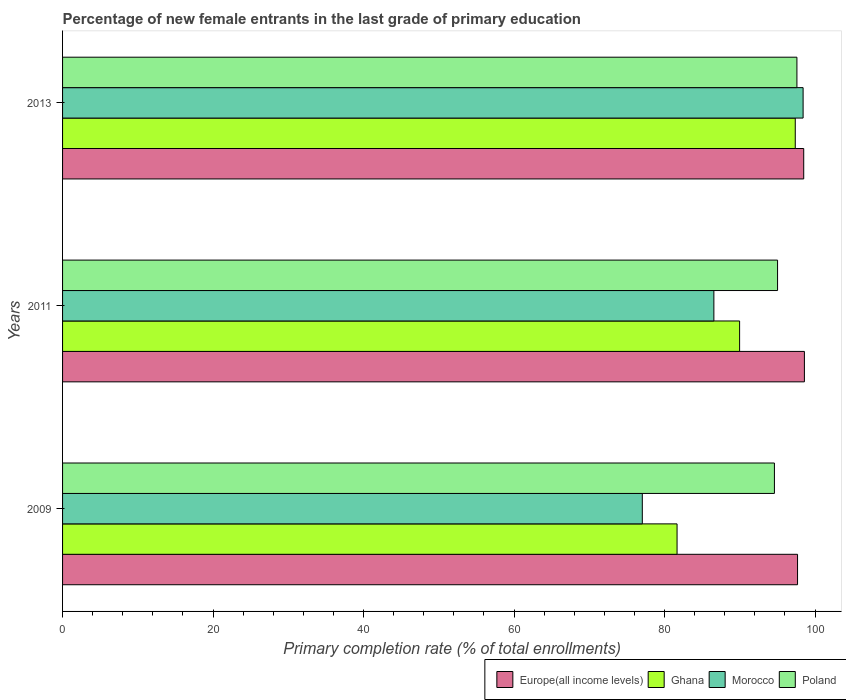How many groups of bars are there?
Ensure brevity in your answer.  3. Are the number of bars on each tick of the Y-axis equal?
Give a very brief answer. Yes. What is the label of the 3rd group of bars from the top?
Provide a succinct answer. 2009. What is the percentage of new female entrants in Morocco in 2013?
Offer a very short reply. 98.41. Across all years, what is the maximum percentage of new female entrants in Ghana?
Make the answer very short. 97.37. Across all years, what is the minimum percentage of new female entrants in Poland?
Your response must be concise. 94.6. In which year was the percentage of new female entrants in Morocco minimum?
Your answer should be compact. 2009. What is the total percentage of new female entrants in Ghana in the graph?
Ensure brevity in your answer.  269. What is the difference between the percentage of new female entrants in Morocco in 2009 and that in 2013?
Give a very brief answer. -21.37. What is the difference between the percentage of new female entrants in Europe(all income levels) in 2009 and the percentage of new female entrants in Morocco in 2013?
Your answer should be compact. -0.74. What is the average percentage of new female entrants in Ghana per year?
Your answer should be very brief. 89.67. In the year 2009, what is the difference between the percentage of new female entrants in Ghana and percentage of new female entrants in Poland?
Ensure brevity in your answer.  -12.94. What is the ratio of the percentage of new female entrants in Europe(all income levels) in 2009 to that in 2011?
Keep it short and to the point. 0.99. What is the difference between the highest and the second highest percentage of new female entrants in Europe(all income levels)?
Offer a terse response. 0.09. What is the difference between the highest and the lowest percentage of new female entrants in Europe(all income levels)?
Ensure brevity in your answer.  0.91. In how many years, is the percentage of new female entrants in Europe(all income levels) greater than the average percentage of new female entrants in Europe(all income levels) taken over all years?
Provide a short and direct response. 2. Is the sum of the percentage of new female entrants in Poland in 2009 and 2011 greater than the maximum percentage of new female entrants in Europe(all income levels) across all years?
Offer a very short reply. Yes. What does the 4th bar from the top in 2013 represents?
Your answer should be compact. Europe(all income levels). What does the 3rd bar from the bottom in 2011 represents?
Ensure brevity in your answer.  Morocco. How many bars are there?
Your answer should be very brief. 12. How many years are there in the graph?
Your answer should be very brief. 3. Are the values on the major ticks of X-axis written in scientific E-notation?
Provide a short and direct response. No. Does the graph contain grids?
Make the answer very short. No. How are the legend labels stacked?
Keep it short and to the point. Horizontal. What is the title of the graph?
Your answer should be compact. Percentage of new female entrants in the last grade of primary education. What is the label or title of the X-axis?
Ensure brevity in your answer.  Primary completion rate (% of total enrollments). What is the label or title of the Y-axis?
Your answer should be compact. Years. What is the Primary completion rate (% of total enrollments) in Europe(all income levels) in 2009?
Your response must be concise. 97.67. What is the Primary completion rate (% of total enrollments) in Ghana in 2009?
Give a very brief answer. 81.66. What is the Primary completion rate (% of total enrollments) in Morocco in 2009?
Offer a terse response. 77.04. What is the Primary completion rate (% of total enrollments) in Poland in 2009?
Give a very brief answer. 94.6. What is the Primary completion rate (% of total enrollments) in Europe(all income levels) in 2011?
Your answer should be very brief. 98.58. What is the Primary completion rate (% of total enrollments) of Ghana in 2011?
Offer a very short reply. 89.97. What is the Primary completion rate (% of total enrollments) of Morocco in 2011?
Provide a short and direct response. 86.55. What is the Primary completion rate (% of total enrollments) in Poland in 2011?
Keep it short and to the point. 95.02. What is the Primary completion rate (% of total enrollments) in Europe(all income levels) in 2013?
Provide a short and direct response. 98.49. What is the Primary completion rate (% of total enrollments) in Ghana in 2013?
Offer a very short reply. 97.37. What is the Primary completion rate (% of total enrollments) in Morocco in 2013?
Make the answer very short. 98.41. What is the Primary completion rate (% of total enrollments) in Poland in 2013?
Keep it short and to the point. 97.59. Across all years, what is the maximum Primary completion rate (% of total enrollments) of Europe(all income levels)?
Offer a very short reply. 98.58. Across all years, what is the maximum Primary completion rate (% of total enrollments) in Ghana?
Offer a very short reply. 97.37. Across all years, what is the maximum Primary completion rate (% of total enrollments) in Morocco?
Offer a terse response. 98.41. Across all years, what is the maximum Primary completion rate (% of total enrollments) in Poland?
Your response must be concise. 97.59. Across all years, what is the minimum Primary completion rate (% of total enrollments) in Europe(all income levels)?
Make the answer very short. 97.67. Across all years, what is the minimum Primary completion rate (% of total enrollments) of Ghana?
Give a very brief answer. 81.66. Across all years, what is the minimum Primary completion rate (% of total enrollments) of Morocco?
Provide a short and direct response. 77.04. Across all years, what is the minimum Primary completion rate (% of total enrollments) in Poland?
Your answer should be compact. 94.6. What is the total Primary completion rate (% of total enrollments) in Europe(all income levels) in the graph?
Provide a succinct answer. 294.75. What is the total Primary completion rate (% of total enrollments) of Ghana in the graph?
Make the answer very short. 269. What is the total Primary completion rate (% of total enrollments) in Morocco in the graph?
Provide a short and direct response. 262. What is the total Primary completion rate (% of total enrollments) in Poland in the graph?
Give a very brief answer. 287.2. What is the difference between the Primary completion rate (% of total enrollments) of Europe(all income levels) in 2009 and that in 2011?
Offer a terse response. -0.91. What is the difference between the Primary completion rate (% of total enrollments) in Ghana in 2009 and that in 2011?
Offer a very short reply. -8.31. What is the difference between the Primary completion rate (% of total enrollments) in Morocco in 2009 and that in 2011?
Ensure brevity in your answer.  -9.51. What is the difference between the Primary completion rate (% of total enrollments) of Poland in 2009 and that in 2011?
Offer a very short reply. -0.42. What is the difference between the Primary completion rate (% of total enrollments) in Europe(all income levels) in 2009 and that in 2013?
Ensure brevity in your answer.  -0.82. What is the difference between the Primary completion rate (% of total enrollments) in Ghana in 2009 and that in 2013?
Provide a short and direct response. -15.71. What is the difference between the Primary completion rate (% of total enrollments) of Morocco in 2009 and that in 2013?
Make the answer very short. -21.37. What is the difference between the Primary completion rate (% of total enrollments) of Poland in 2009 and that in 2013?
Ensure brevity in your answer.  -2.99. What is the difference between the Primary completion rate (% of total enrollments) of Europe(all income levels) in 2011 and that in 2013?
Your response must be concise. 0.09. What is the difference between the Primary completion rate (% of total enrollments) in Ghana in 2011 and that in 2013?
Your answer should be very brief. -7.4. What is the difference between the Primary completion rate (% of total enrollments) in Morocco in 2011 and that in 2013?
Provide a short and direct response. -11.86. What is the difference between the Primary completion rate (% of total enrollments) of Poland in 2011 and that in 2013?
Your response must be concise. -2.57. What is the difference between the Primary completion rate (% of total enrollments) of Europe(all income levels) in 2009 and the Primary completion rate (% of total enrollments) of Morocco in 2011?
Offer a very short reply. 11.12. What is the difference between the Primary completion rate (% of total enrollments) of Europe(all income levels) in 2009 and the Primary completion rate (% of total enrollments) of Poland in 2011?
Your response must be concise. 2.66. What is the difference between the Primary completion rate (% of total enrollments) of Ghana in 2009 and the Primary completion rate (% of total enrollments) of Morocco in 2011?
Offer a very short reply. -4.89. What is the difference between the Primary completion rate (% of total enrollments) of Ghana in 2009 and the Primary completion rate (% of total enrollments) of Poland in 2011?
Your answer should be very brief. -13.36. What is the difference between the Primary completion rate (% of total enrollments) of Morocco in 2009 and the Primary completion rate (% of total enrollments) of Poland in 2011?
Provide a short and direct response. -17.97. What is the difference between the Primary completion rate (% of total enrollments) of Europe(all income levels) in 2009 and the Primary completion rate (% of total enrollments) of Ghana in 2013?
Provide a short and direct response. 0.3. What is the difference between the Primary completion rate (% of total enrollments) in Europe(all income levels) in 2009 and the Primary completion rate (% of total enrollments) in Morocco in 2013?
Provide a succinct answer. -0.74. What is the difference between the Primary completion rate (% of total enrollments) of Europe(all income levels) in 2009 and the Primary completion rate (% of total enrollments) of Poland in 2013?
Ensure brevity in your answer.  0.08. What is the difference between the Primary completion rate (% of total enrollments) in Ghana in 2009 and the Primary completion rate (% of total enrollments) in Morocco in 2013?
Your response must be concise. -16.75. What is the difference between the Primary completion rate (% of total enrollments) of Ghana in 2009 and the Primary completion rate (% of total enrollments) of Poland in 2013?
Provide a short and direct response. -15.93. What is the difference between the Primary completion rate (% of total enrollments) in Morocco in 2009 and the Primary completion rate (% of total enrollments) in Poland in 2013?
Provide a short and direct response. -20.55. What is the difference between the Primary completion rate (% of total enrollments) in Europe(all income levels) in 2011 and the Primary completion rate (% of total enrollments) in Ghana in 2013?
Make the answer very short. 1.21. What is the difference between the Primary completion rate (% of total enrollments) in Europe(all income levels) in 2011 and the Primary completion rate (% of total enrollments) in Morocco in 2013?
Provide a succinct answer. 0.17. What is the difference between the Primary completion rate (% of total enrollments) in Europe(all income levels) in 2011 and the Primary completion rate (% of total enrollments) in Poland in 2013?
Give a very brief answer. 0.99. What is the difference between the Primary completion rate (% of total enrollments) of Ghana in 2011 and the Primary completion rate (% of total enrollments) of Morocco in 2013?
Offer a terse response. -8.44. What is the difference between the Primary completion rate (% of total enrollments) in Ghana in 2011 and the Primary completion rate (% of total enrollments) in Poland in 2013?
Ensure brevity in your answer.  -7.62. What is the difference between the Primary completion rate (% of total enrollments) in Morocco in 2011 and the Primary completion rate (% of total enrollments) in Poland in 2013?
Offer a very short reply. -11.04. What is the average Primary completion rate (% of total enrollments) of Europe(all income levels) per year?
Ensure brevity in your answer.  98.25. What is the average Primary completion rate (% of total enrollments) in Ghana per year?
Your answer should be compact. 89.67. What is the average Primary completion rate (% of total enrollments) in Morocco per year?
Your response must be concise. 87.33. What is the average Primary completion rate (% of total enrollments) in Poland per year?
Give a very brief answer. 95.73. In the year 2009, what is the difference between the Primary completion rate (% of total enrollments) of Europe(all income levels) and Primary completion rate (% of total enrollments) of Ghana?
Keep it short and to the point. 16.01. In the year 2009, what is the difference between the Primary completion rate (% of total enrollments) of Europe(all income levels) and Primary completion rate (% of total enrollments) of Morocco?
Make the answer very short. 20.63. In the year 2009, what is the difference between the Primary completion rate (% of total enrollments) in Europe(all income levels) and Primary completion rate (% of total enrollments) in Poland?
Make the answer very short. 3.07. In the year 2009, what is the difference between the Primary completion rate (% of total enrollments) in Ghana and Primary completion rate (% of total enrollments) in Morocco?
Your answer should be compact. 4.62. In the year 2009, what is the difference between the Primary completion rate (% of total enrollments) of Ghana and Primary completion rate (% of total enrollments) of Poland?
Make the answer very short. -12.94. In the year 2009, what is the difference between the Primary completion rate (% of total enrollments) of Morocco and Primary completion rate (% of total enrollments) of Poland?
Give a very brief answer. -17.56. In the year 2011, what is the difference between the Primary completion rate (% of total enrollments) in Europe(all income levels) and Primary completion rate (% of total enrollments) in Ghana?
Keep it short and to the point. 8.61. In the year 2011, what is the difference between the Primary completion rate (% of total enrollments) in Europe(all income levels) and Primary completion rate (% of total enrollments) in Morocco?
Give a very brief answer. 12.03. In the year 2011, what is the difference between the Primary completion rate (% of total enrollments) in Europe(all income levels) and Primary completion rate (% of total enrollments) in Poland?
Offer a very short reply. 3.57. In the year 2011, what is the difference between the Primary completion rate (% of total enrollments) of Ghana and Primary completion rate (% of total enrollments) of Morocco?
Your answer should be very brief. 3.42. In the year 2011, what is the difference between the Primary completion rate (% of total enrollments) in Ghana and Primary completion rate (% of total enrollments) in Poland?
Provide a short and direct response. -5.04. In the year 2011, what is the difference between the Primary completion rate (% of total enrollments) of Morocco and Primary completion rate (% of total enrollments) of Poland?
Keep it short and to the point. -8.46. In the year 2013, what is the difference between the Primary completion rate (% of total enrollments) in Europe(all income levels) and Primary completion rate (% of total enrollments) in Ghana?
Offer a very short reply. 1.12. In the year 2013, what is the difference between the Primary completion rate (% of total enrollments) in Europe(all income levels) and Primary completion rate (% of total enrollments) in Morocco?
Give a very brief answer. 0.08. In the year 2013, what is the difference between the Primary completion rate (% of total enrollments) of Europe(all income levels) and Primary completion rate (% of total enrollments) of Poland?
Your response must be concise. 0.9. In the year 2013, what is the difference between the Primary completion rate (% of total enrollments) of Ghana and Primary completion rate (% of total enrollments) of Morocco?
Keep it short and to the point. -1.04. In the year 2013, what is the difference between the Primary completion rate (% of total enrollments) of Ghana and Primary completion rate (% of total enrollments) of Poland?
Ensure brevity in your answer.  -0.22. In the year 2013, what is the difference between the Primary completion rate (% of total enrollments) in Morocco and Primary completion rate (% of total enrollments) in Poland?
Give a very brief answer. 0.82. What is the ratio of the Primary completion rate (% of total enrollments) in Europe(all income levels) in 2009 to that in 2011?
Make the answer very short. 0.99. What is the ratio of the Primary completion rate (% of total enrollments) of Ghana in 2009 to that in 2011?
Your response must be concise. 0.91. What is the ratio of the Primary completion rate (% of total enrollments) in Morocco in 2009 to that in 2011?
Provide a short and direct response. 0.89. What is the ratio of the Primary completion rate (% of total enrollments) in Europe(all income levels) in 2009 to that in 2013?
Your answer should be compact. 0.99. What is the ratio of the Primary completion rate (% of total enrollments) of Ghana in 2009 to that in 2013?
Your response must be concise. 0.84. What is the ratio of the Primary completion rate (% of total enrollments) in Morocco in 2009 to that in 2013?
Give a very brief answer. 0.78. What is the ratio of the Primary completion rate (% of total enrollments) of Poland in 2009 to that in 2013?
Your answer should be very brief. 0.97. What is the ratio of the Primary completion rate (% of total enrollments) of Ghana in 2011 to that in 2013?
Your response must be concise. 0.92. What is the ratio of the Primary completion rate (% of total enrollments) of Morocco in 2011 to that in 2013?
Offer a very short reply. 0.88. What is the ratio of the Primary completion rate (% of total enrollments) in Poland in 2011 to that in 2013?
Your answer should be very brief. 0.97. What is the difference between the highest and the second highest Primary completion rate (% of total enrollments) in Europe(all income levels)?
Give a very brief answer. 0.09. What is the difference between the highest and the second highest Primary completion rate (% of total enrollments) in Ghana?
Your answer should be compact. 7.4. What is the difference between the highest and the second highest Primary completion rate (% of total enrollments) of Morocco?
Your answer should be compact. 11.86. What is the difference between the highest and the second highest Primary completion rate (% of total enrollments) of Poland?
Offer a terse response. 2.57. What is the difference between the highest and the lowest Primary completion rate (% of total enrollments) of Europe(all income levels)?
Offer a terse response. 0.91. What is the difference between the highest and the lowest Primary completion rate (% of total enrollments) in Ghana?
Your response must be concise. 15.71. What is the difference between the highest and the lowest Primary completion rate (% of total enrollments) in Morocco?
Give a very brief answer. 21.37. What is the difference between the highest and the lowest Primary completion rate (% of total enrollments) of Poland?
Provide a succinct answer. 2.99. 